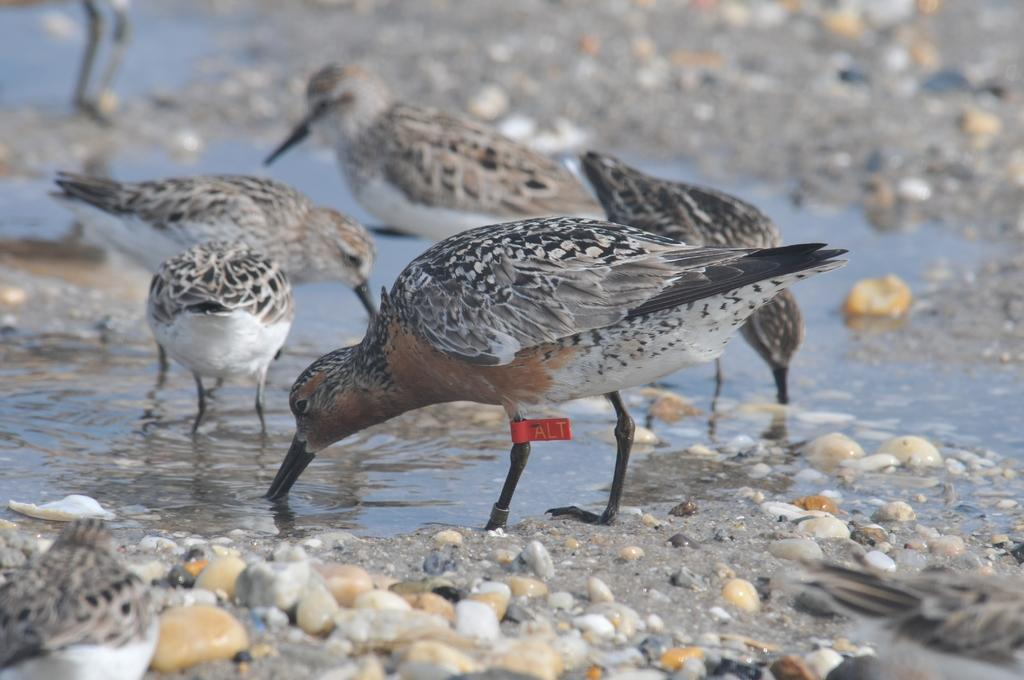What type of animals can be seen in the image? There are birds in the image. What are the birds doing in the image? The birds are drinking water. What type of terrain is visible in the image? There is soil, stones, and pebbles in the image. Can you describe any unique feature of one of the birds? One bird has a red color bandage on its leg. What type of net is being used by the birds to catch fish in the image? There is no net present in the image, and the birds are not shown catching fish. 